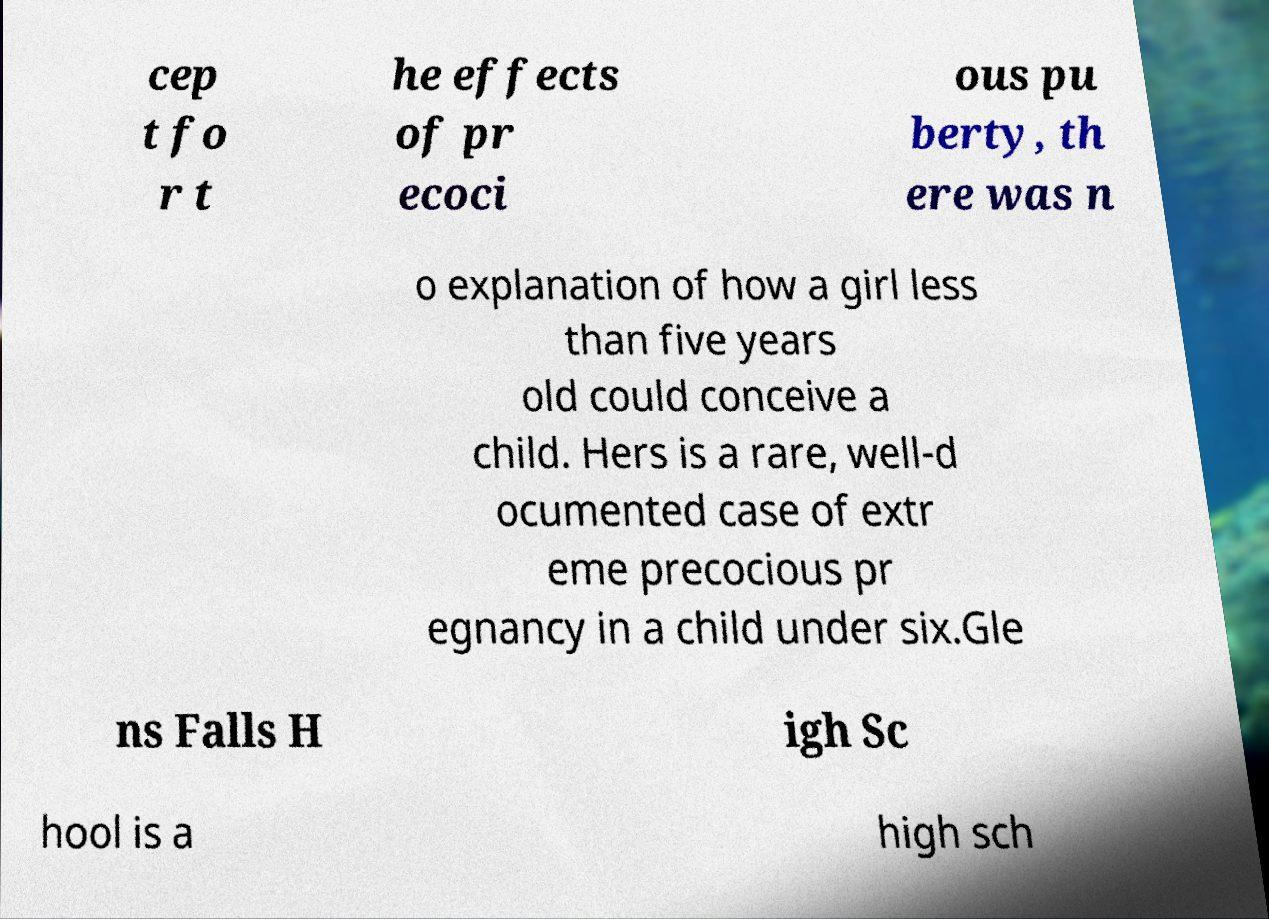Could you extract and type out the text from this image? cep t fo r t he effects of pr ecoci ous pu berty, th ere was n o explanation of how a girl less than five years old could conceive a child. Hers is a rare, well-d ocumented case of extr eme precocious pr egnancy in a child under six.Gle ns Falls H igh Sc hool is a high sch 